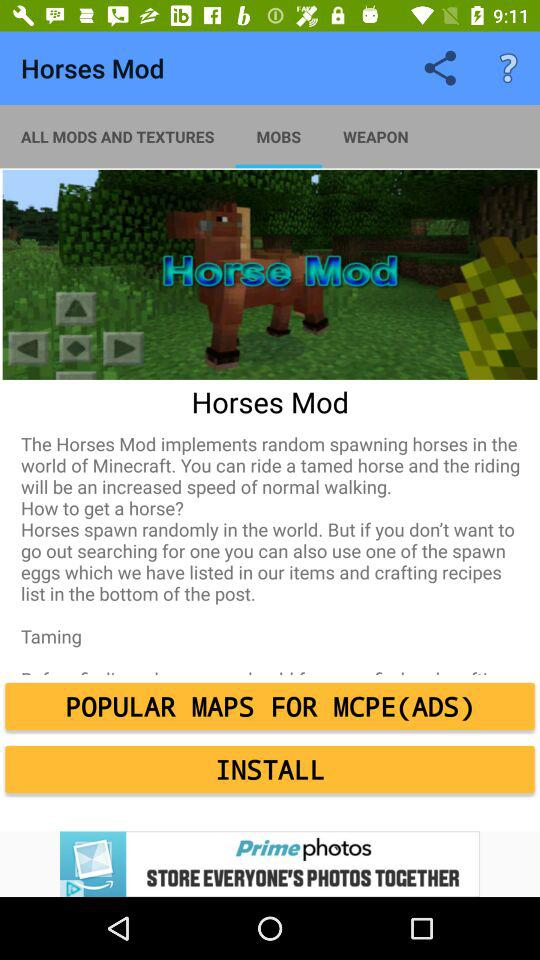Which tab is selected? The selected tab is "MOBS". 